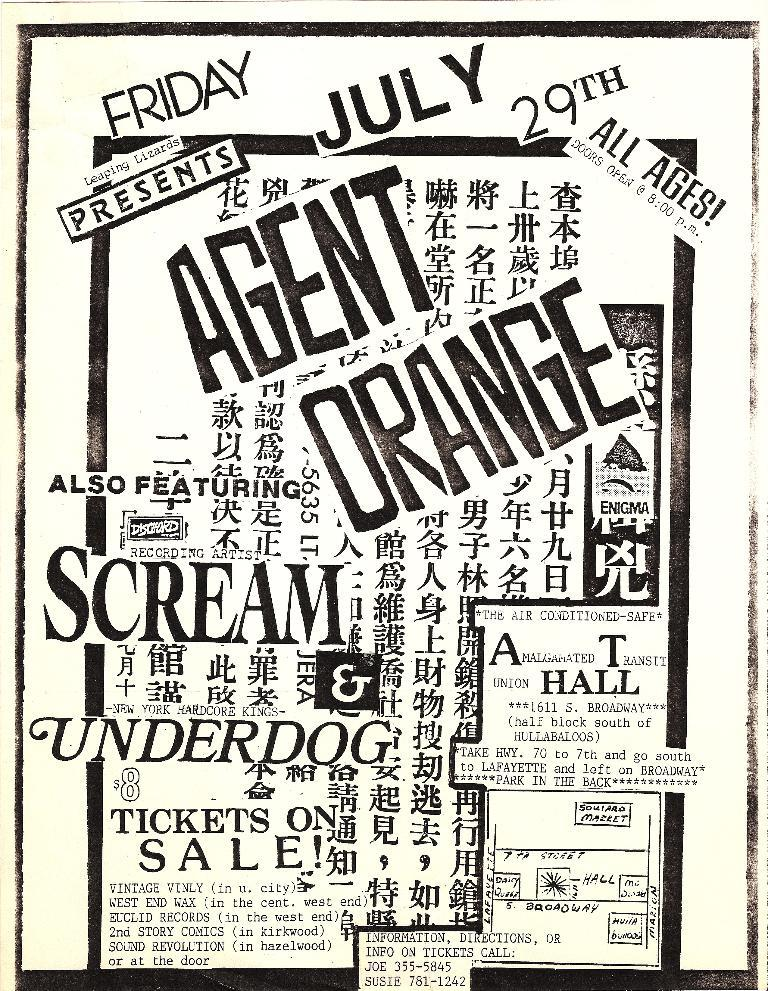<image>
Give a short and clear explanation of the subsequent image. An advertisement for Friday July, 29th featuring Agent Orange. 